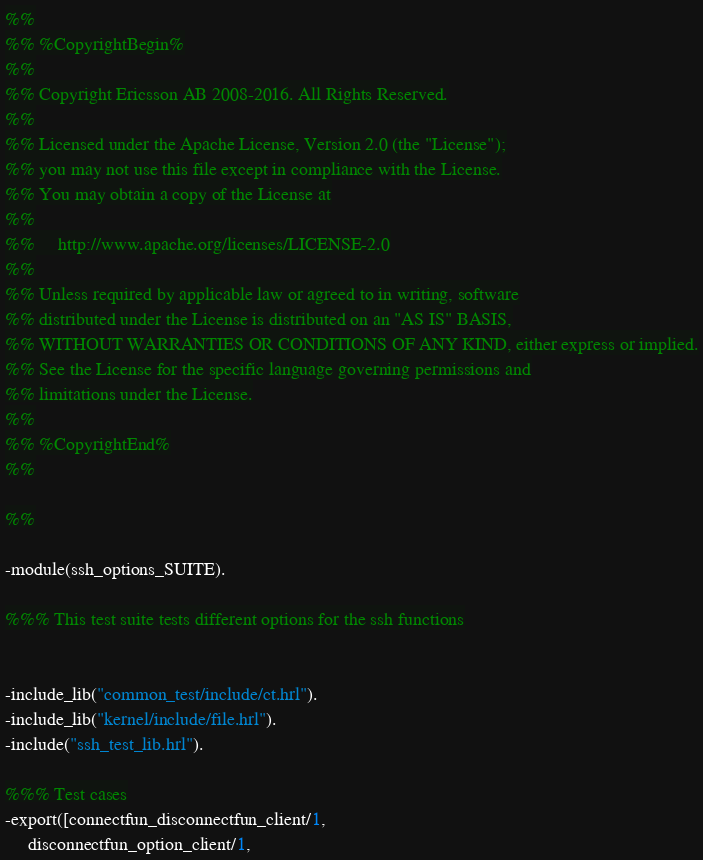<code> <loc_0><loc_0><loc_500><loc_500><_Erlang_>%%
%% %CopyrightBegin%
%%
%% Copyright Ericsson AB 2008-2016. All Rights Reserved.
%%
%% Licensed under the Apache License, Version 2.0 (the "License");
%% you may not use this file except in compliance with the License.
%% You may obtain a copy of the License at
%%
%%     http://www.apache.org/licenses/LICENSE-2.0
%%
%% Unless required by applicable law or agreed to in writing, software
%% distributed under the License is distributed on an "AS IS" BASIS,
%% WITHOUT WARRANTIES OR CONDITIONS OF ANY KIND, either express or implied.
%% See the License for the specific language governing permissions and
%% limitations under the License.
%%
%% %CopyrightEnd%
%%

%%

-module(ssh_options_SUITE).

%%% This test suite tests different options for the ssh functions


-include_lib("common_test/include/ct.hrl").
-include_lib("kernel/include/file.hrl").
-include("ssh_test_lib.hrl").

%%% Test cases
-export([connectfun_disconnectfun_client/1, 
	 disconnectfun_option_client/1, </code> 